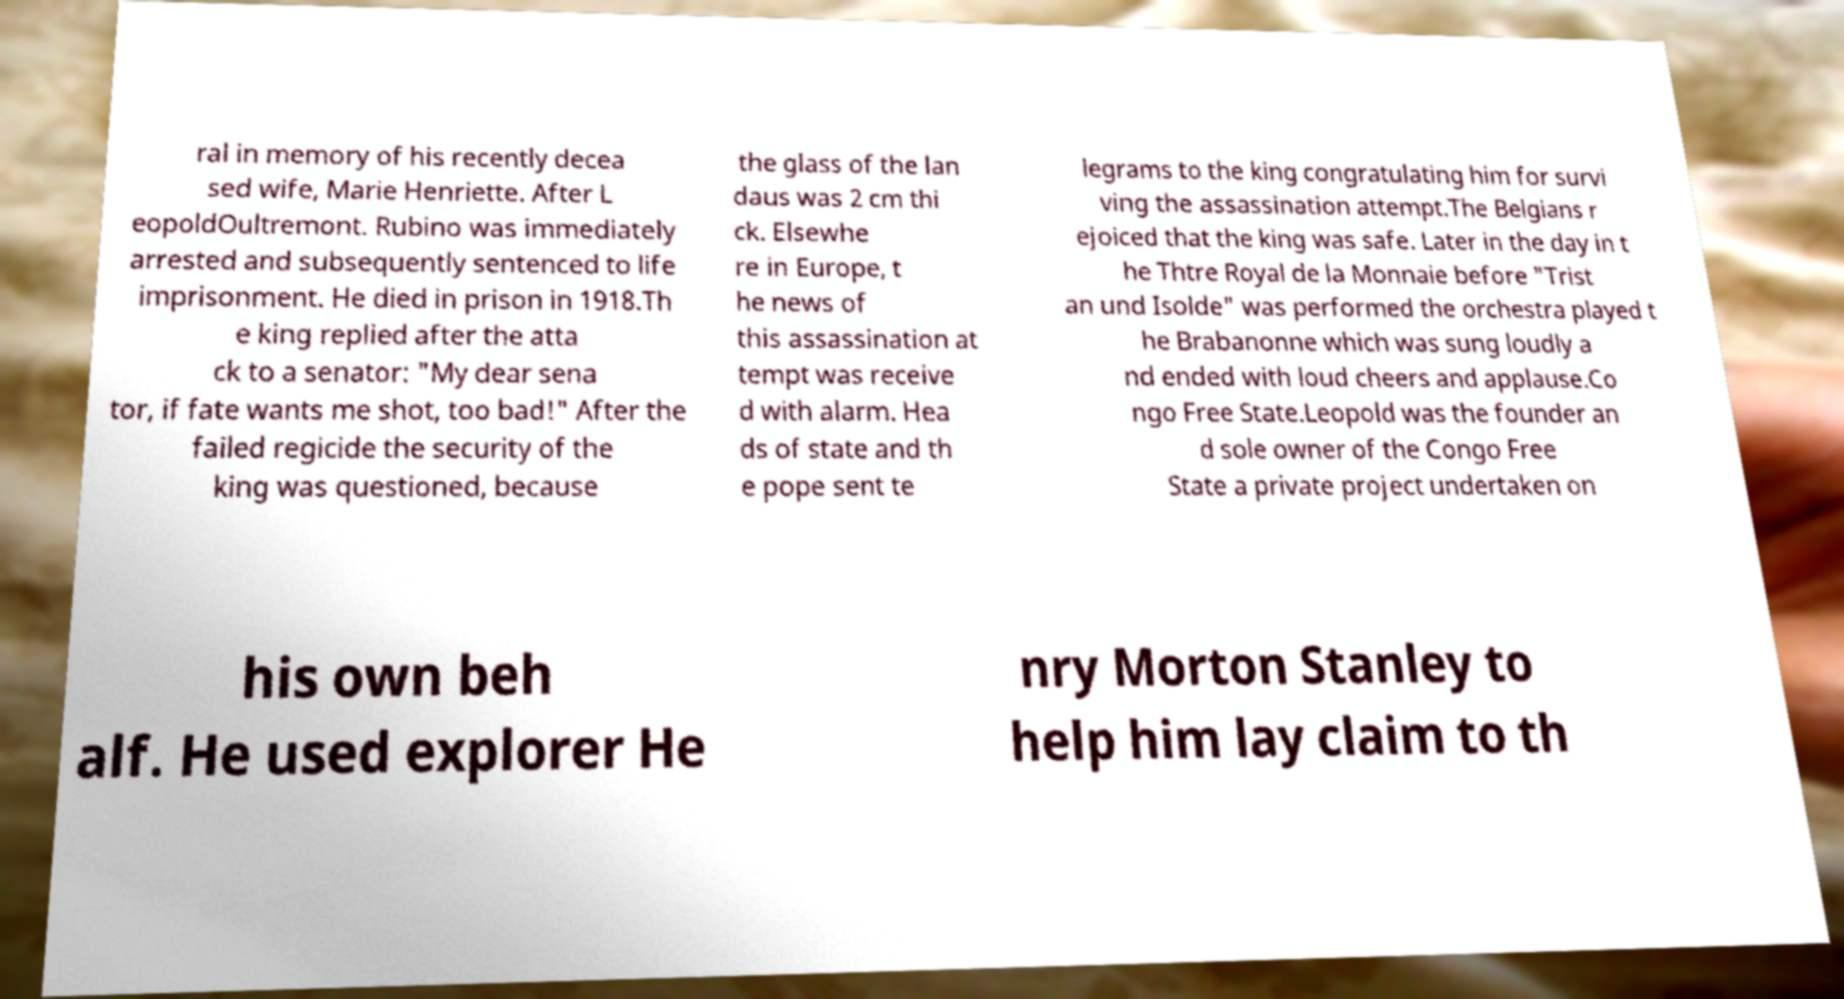Please identify and transcribe the text found in this image. ral in memory of his recently decea sed wife, Marie Henriette. After L eopoldOultremont. Rubino was immediately arrested and subsequently sentenced to life imprisonment. He died in prison in 1918.Th e king replied after the atta ck to a senator: "My dear sena tor, if fate wants me shot, too bad!" After the failed regicide the security of the king was questioned, because the glass of the lan daus was 2 cm thi ck. Elsewhe re in Europe, t he news of this assassination at tempt was receive d with alarm. Hea ds of state and th e pope sent te legrams to the king congratulating him for survi ving the assassination attempt.The Belgians r ejoiced that the king was safe. Later in the day in t he Thtre Royal de la Monnaie before "Trist an und Isolde" was performed the orchestra played t he Brabanonne which was sung loudly a nd ended with loud cheers and applause.Co ngo Free State.Leopold was the founder an d sole owner of the Congo Free State a private project undertaken on his own beh alf. He used explorer He nry Morton Stanley to help him lay claim to th 